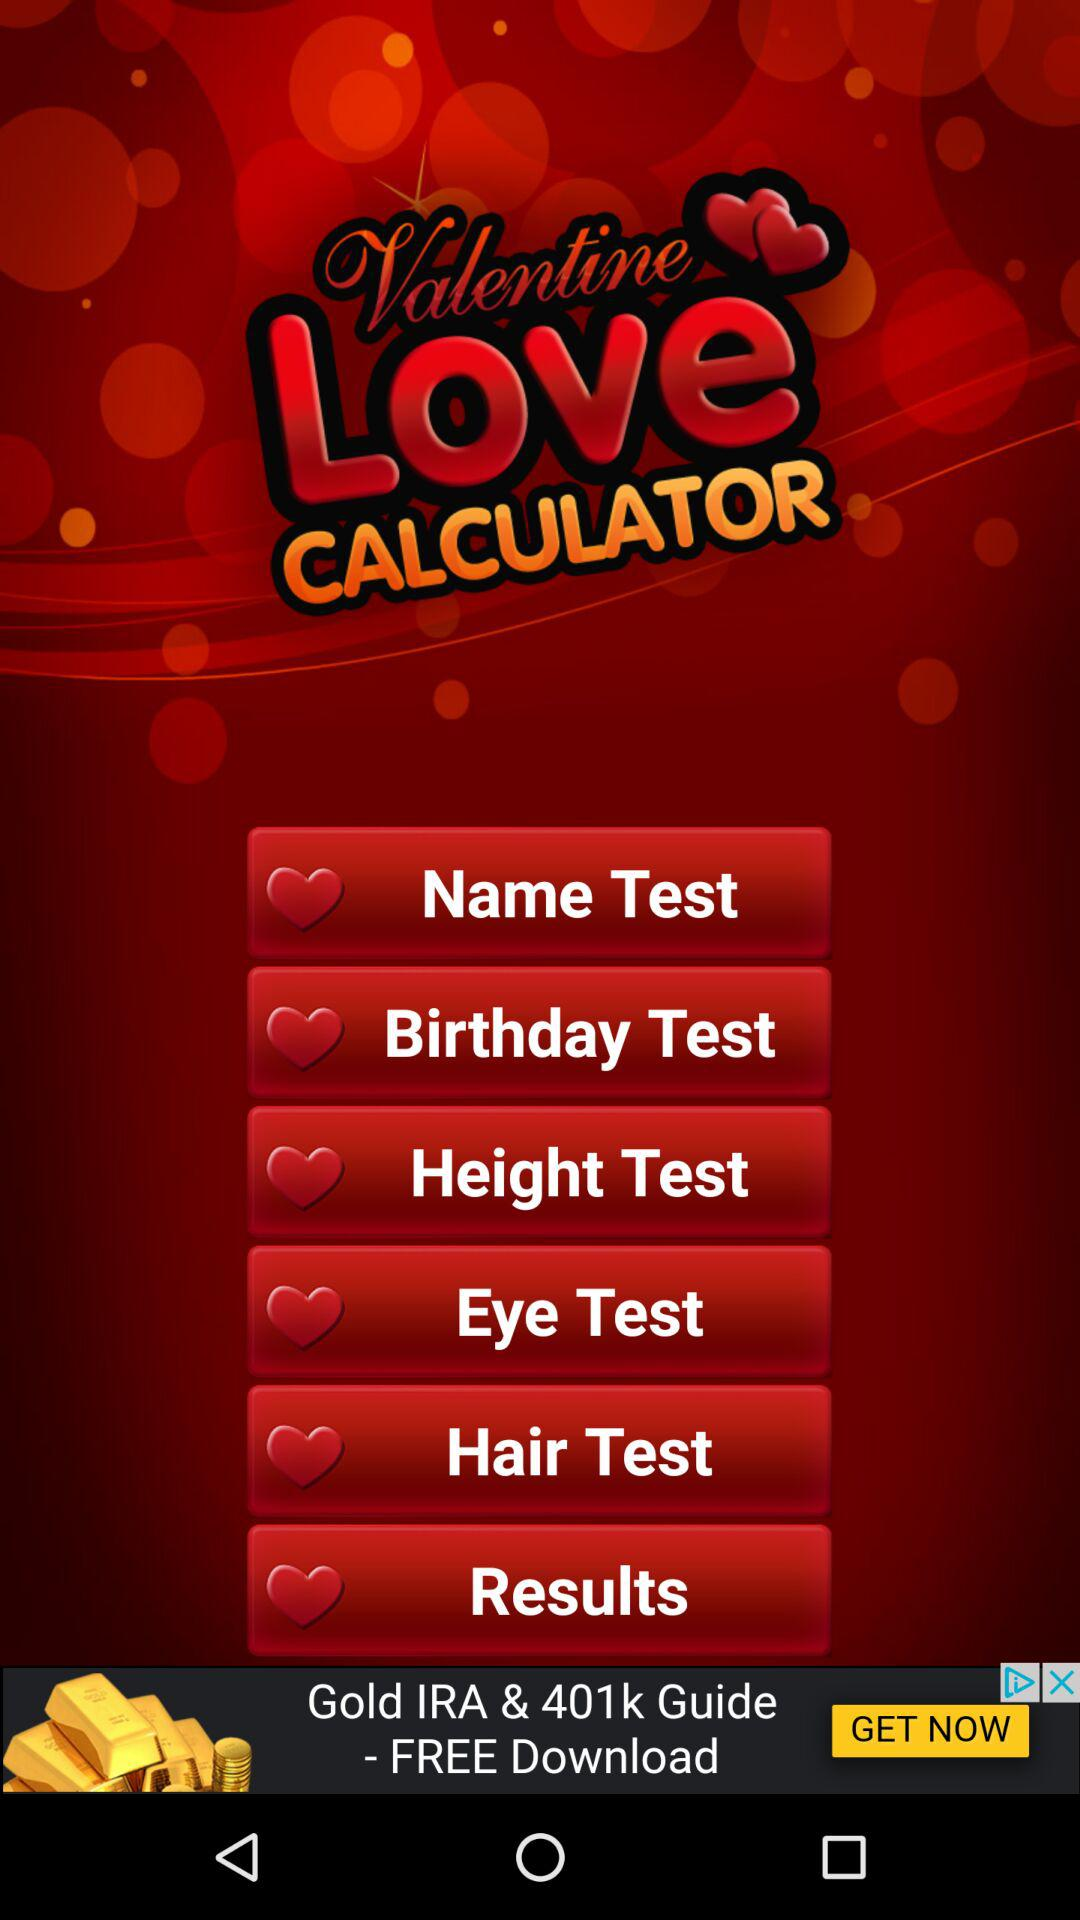What is the name of the application? The name of the application is "Valentine Love CALCULATOR". 